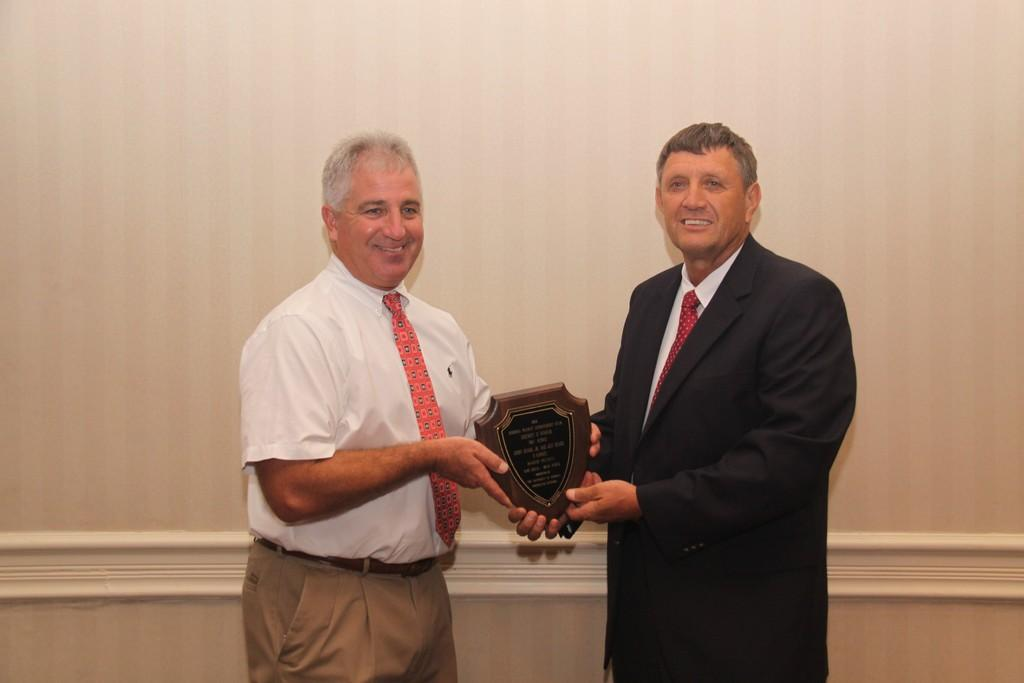How many people are in the image? There are two men in the image. What are the men holding in the image? The men are holding a shield. What can be seen in the background of the image? There is a wall in the background of the image. What type of story is being told by the men in the image? There is no indication in the image that the men are telling a story, so it cannot be determined from the picture. 